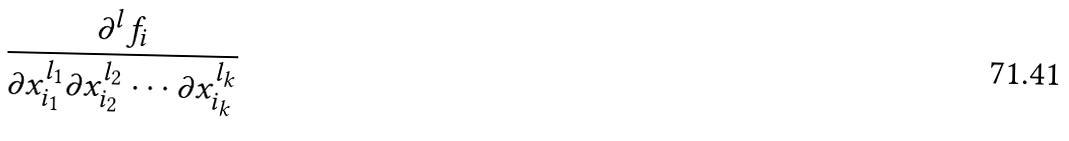<formula> <loc_0><loc_0><loc_500><loc_500>\frac { \partial ^ { l } f _ { i } } { \partial x _ { i _ { 1 } } ^ { l _ { 1 } } \partial x _ { i _ { 2 } } ^ { l _ { 2 } } \cdot \cdot \cdot \partial x _ { i _ { k } } ^ { l _ { k } } }</formula> 